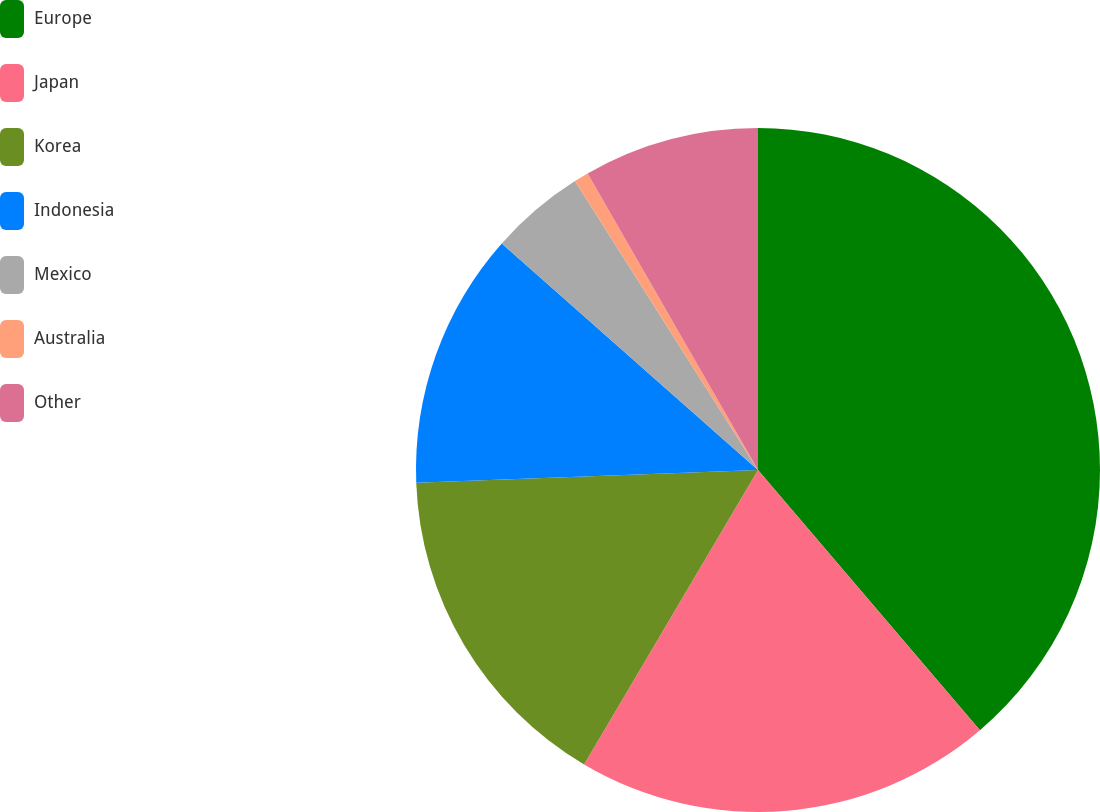Convert chart to OTSL. <chart><loc_0><loc_0><loc_500><loc_500><pie_chart><fcel>Europe<fcel>Japan<fcel>Korea<fcel>Indonesia<fcel>Mexico<fcel>Australia<fcel>Other<nl><fcel>38.76%<fcel>19.73%<fcel>15.92%<fcel>12.11%<fcel>4.49%<fcel>0.69%<fcel>8.3%<nl></chart> 